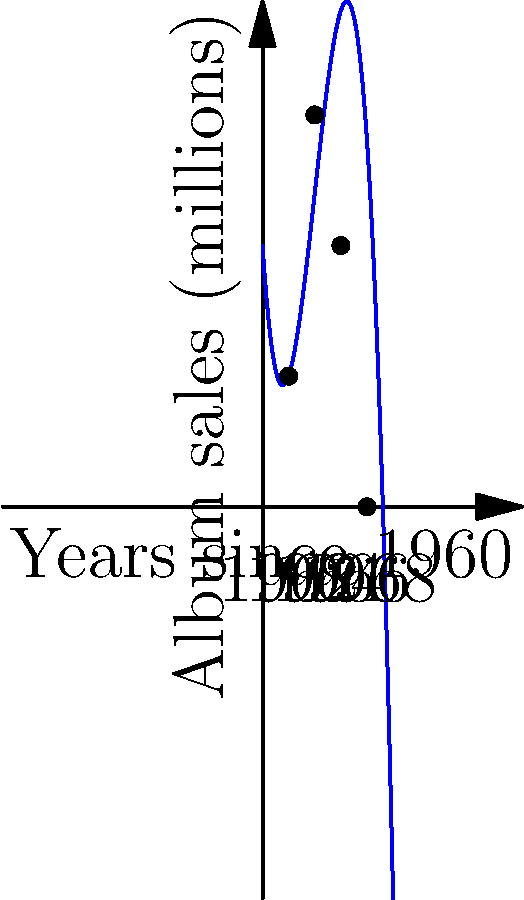As a passionate fan of rock and roll music, you're analyzing the sales trend of Crickets albums from 1960 to 1970. The graph shows album sales (in millions) over time, fitted with a third-degree polynomial. Based on this trend, in which year did the Crickets likely experience their peak album sales? To find the year of peak album sales, we need to follow these steps:

1. Observe that the polynomial graph reaches its maximum point between 1962 and 1966.

2. The x-axis represents years since 1960, so we need to find the x-coordinate of the maximum point.

3. For a third-degree polynomial $f(x) = ax^3 + bx^2 + cx + d$, the maximum occurs where $f'(x) = 0$.

4. The derivative is $f'(x) = 3ax^2 + 2bx + c$.

5. Setting $f'(x) = 0$ and solving for x gives the x-coordinate of the maximum.

6. From the graph, we can estimate that the maximum occurs around x = 4, which corresponds to 1964.

7. To confirm, we can check that the sales are increasing before 1964 and decreasing after 1964.

Therefore, the Crickets likely experienced their peak album sales in 1964.
Answer: 1964 